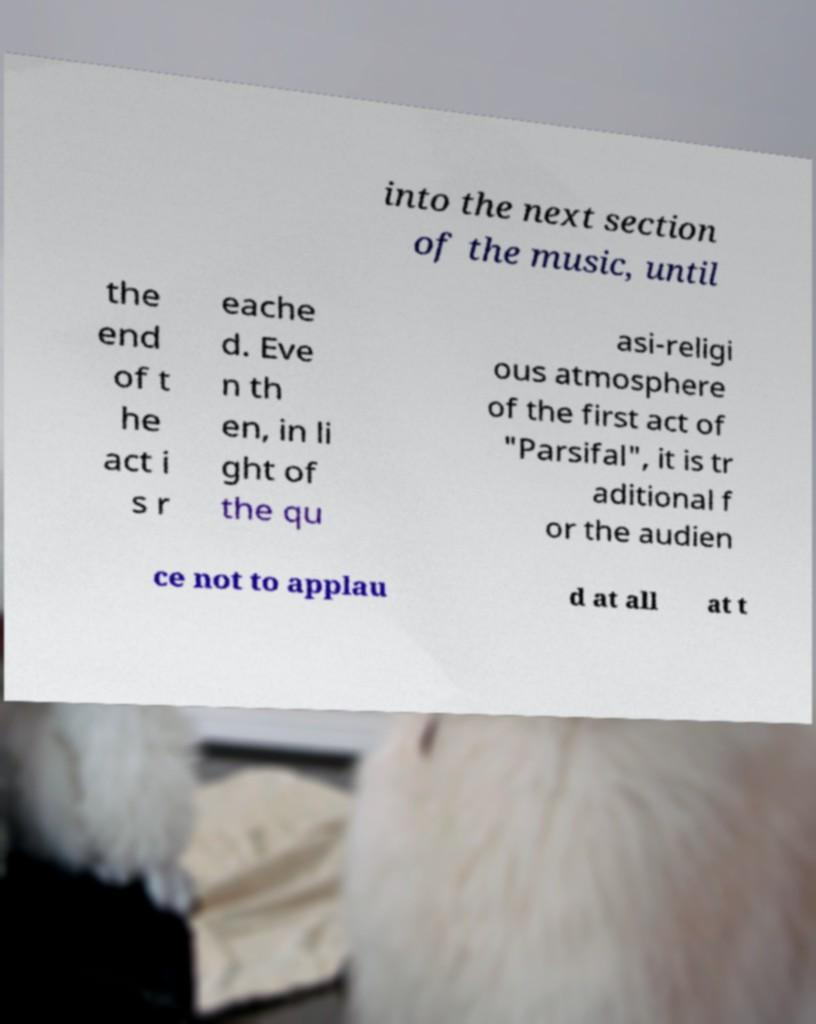Can you read and provide the text displayed in the image?This photo seems to have some interesting text. Can you extract and type it out for me? into the next section of the music, until the end of t he act i s r eache d. Eve n th en, in li ght of the qu asi-religi ous atmosphere of the first act of "Parsifal", it is tr aditional f or the audien ce not to applau d at all at t 